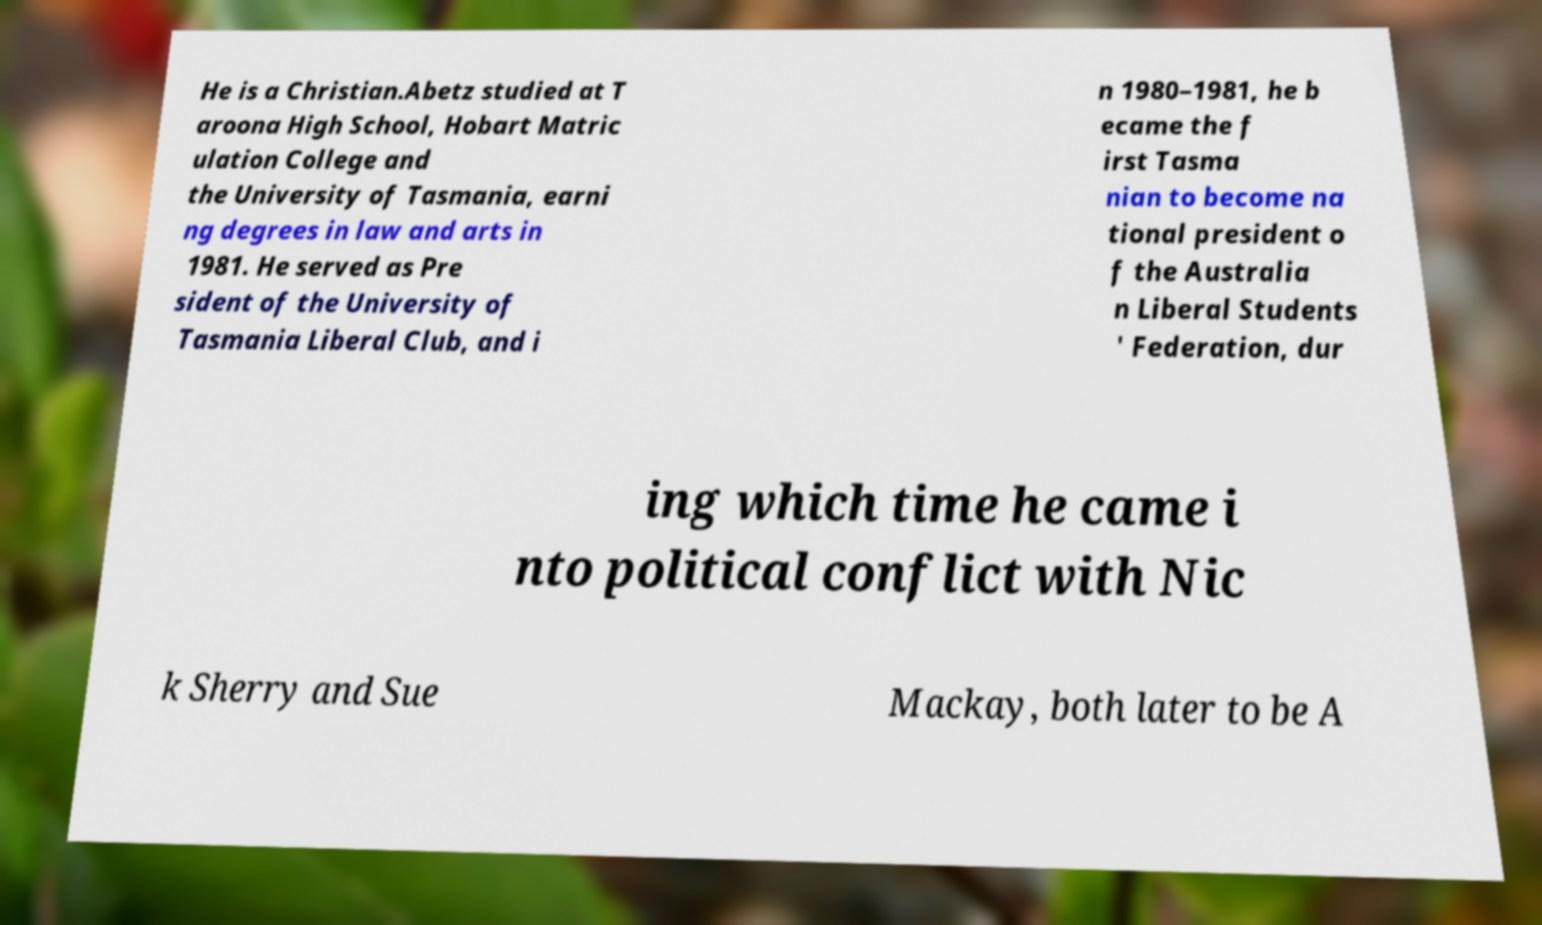There's text embedded in this image that I need extracted. Can you transcribe it verbatim? He is a Christian.Abetz studied at T aroona High School, Hobart Matric ulation College and the University of Tasmania, earni ng degrees in law and arts in 1981. He served as Pre sident of the University of Tasmania Liberal Club, and i n 1980–1981, he b ecame the f irst Tasma nian to become na tional president o f the Australia n Liberal Students ' Federation, dur ing which time he came i nto political conflict with Nic k Sherry and Sue Mackay, both later to be A 